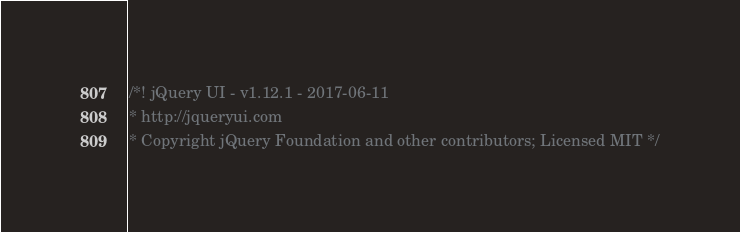<code> <loc_0><loc_0><loc_500><loc_500><_CSS_>/*! jQuery UI - v1.12.1 - 2017-06-11
* http://jqueryui.com
* Copyright jQuery Foundation and other contributors; Licensed MIT */
</code> 